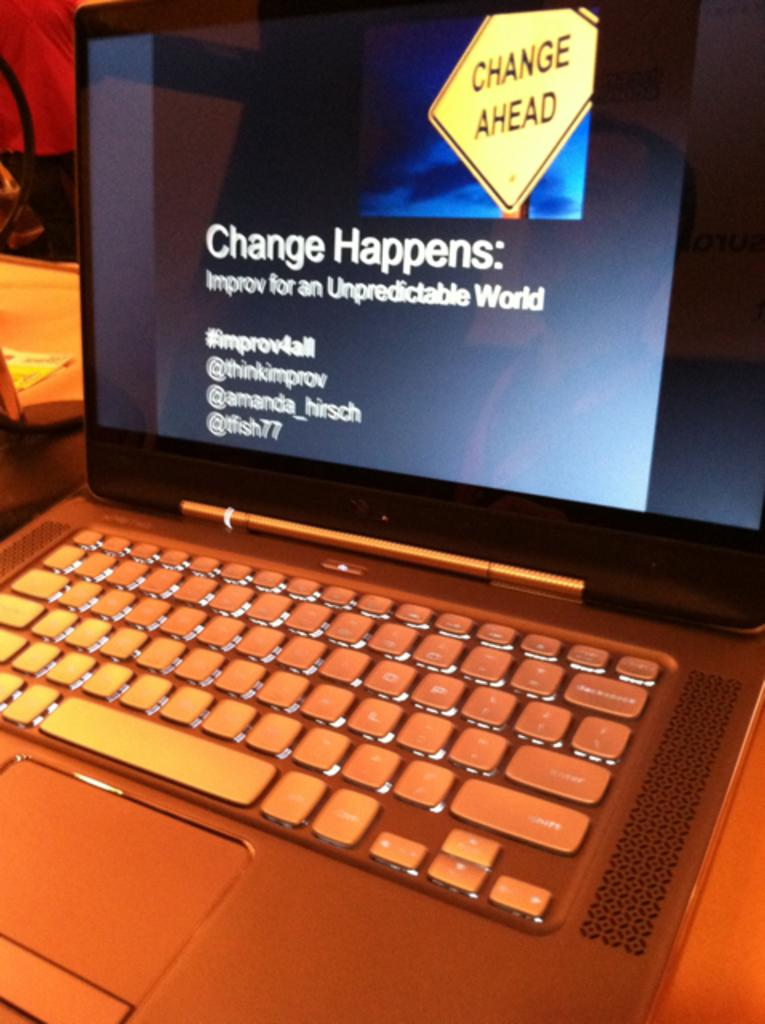<image>
Relay a brief, clear account of the picture shown. Laptop with a monitor that shows "Change Happens". 